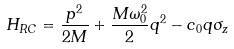<formula> <loc_0><loc_0><loc_500><loc_500>H _ { R C } = \frac { p ^ { 2 } } { 2 M } + \frac { M \omega _ { 0 } ^ { 2 } } { 2 } q ^ { 2 } - c _ { 0 } q \sigma _ { z }</formula> 